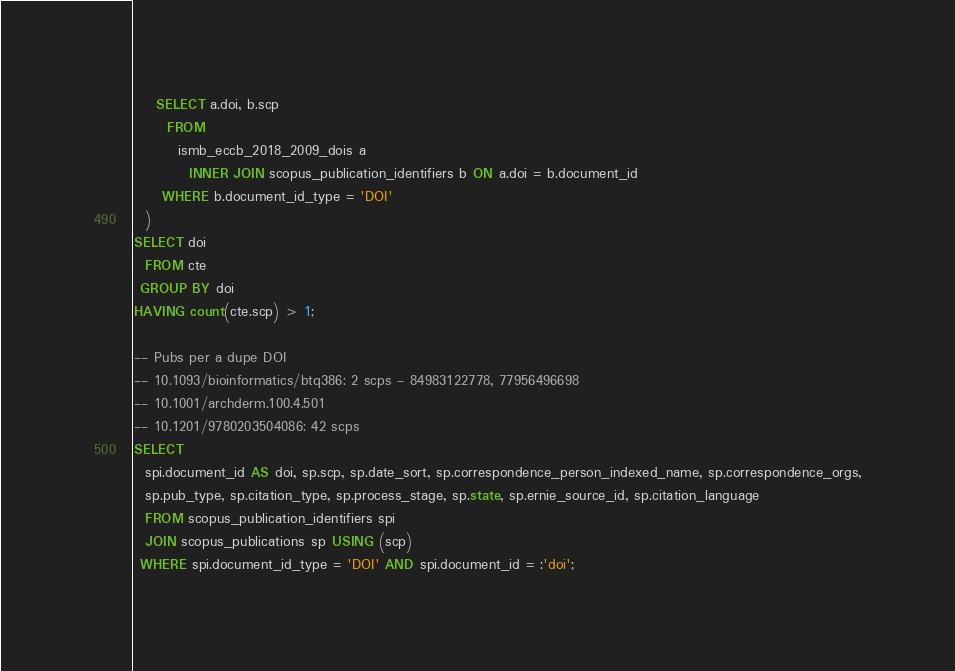Convert code to text. <code><loc_0><loc_0><loc_500><loc_500><_SQL_>    SELECT a.doi, b.scp
      FROM
        ismb_eccb_2018_2009_dois a
          INNER JOIN scopus_publication_identifiers b ON a.doi = b.document_id
     WHERE b.document_id_type = 'DOI'
  )
SELECT doi
  FROM cte
 GROUP BY doi
HAVING count(cte.scp) > 1;

-- Pubs per a dupe DOI
-- 10.1093/bioinformatics/btq386: 2 scps - 84983122778, 77956496698
-- 10.1001/archderm.100.4.501
-- 10.1201/9780203504086: 42 scps
SELECT
  spi.document_id AS doi, sp.scp, sp.date_sort, sp.correspondence_person_indexed_name, sp.correspondence_orgs,
  sp.pub_type, sp.citation_type, sp.process_stage, sp.state, sp.ernie_source_id, sp.citation_language
  FROM scopus_publication_identifiers spi
  JOIN scopus_publications sp USING (scp)
 WHERE spi.document_id_type = 'DOI' AND spi.document_id = :'doi';
</code> 